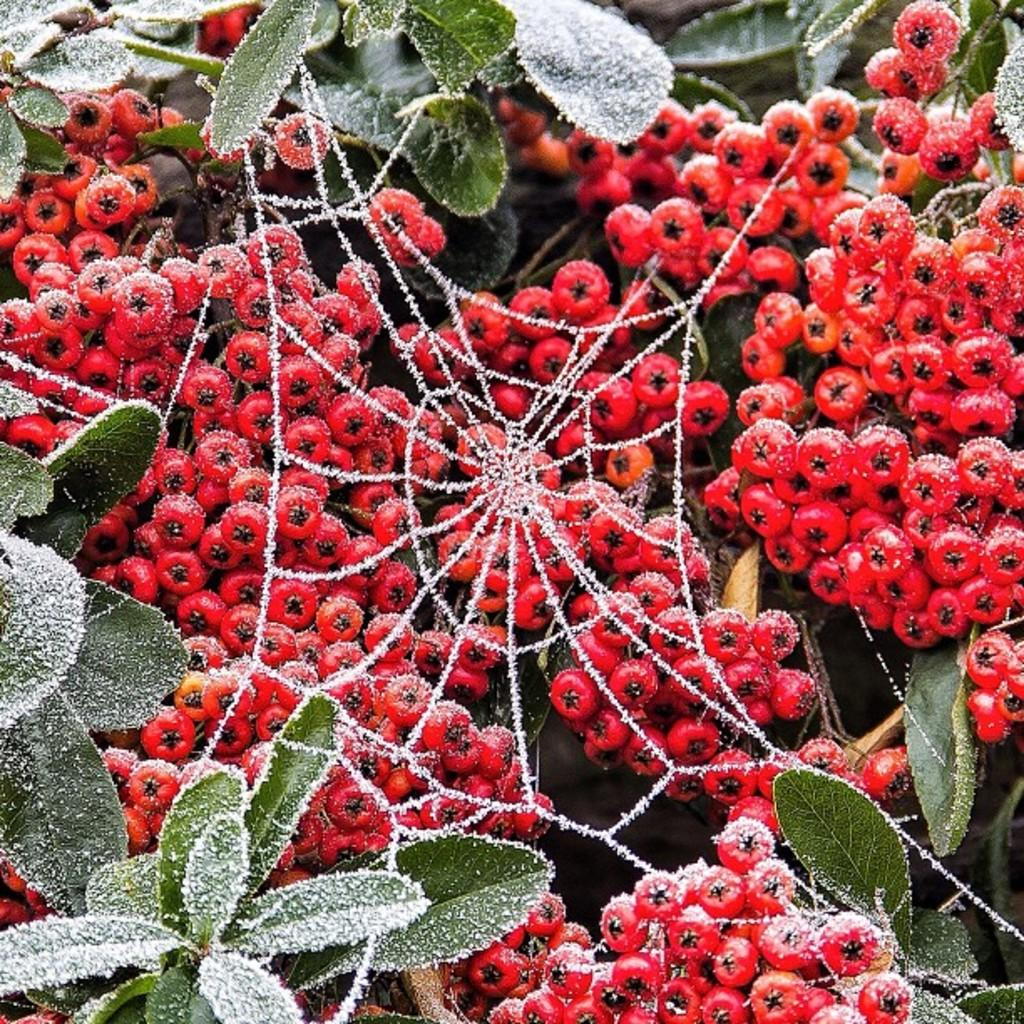What type of food items can be seen in the image? There are fruits in the image. What other living organisms are present in the image? There are plants in the image. What additional element can be observed in the image? There is a web in the image. What route do the cherries take to reach the plants in the image? There is no mention of cherries in the image, so we cannot determine a route for them. 